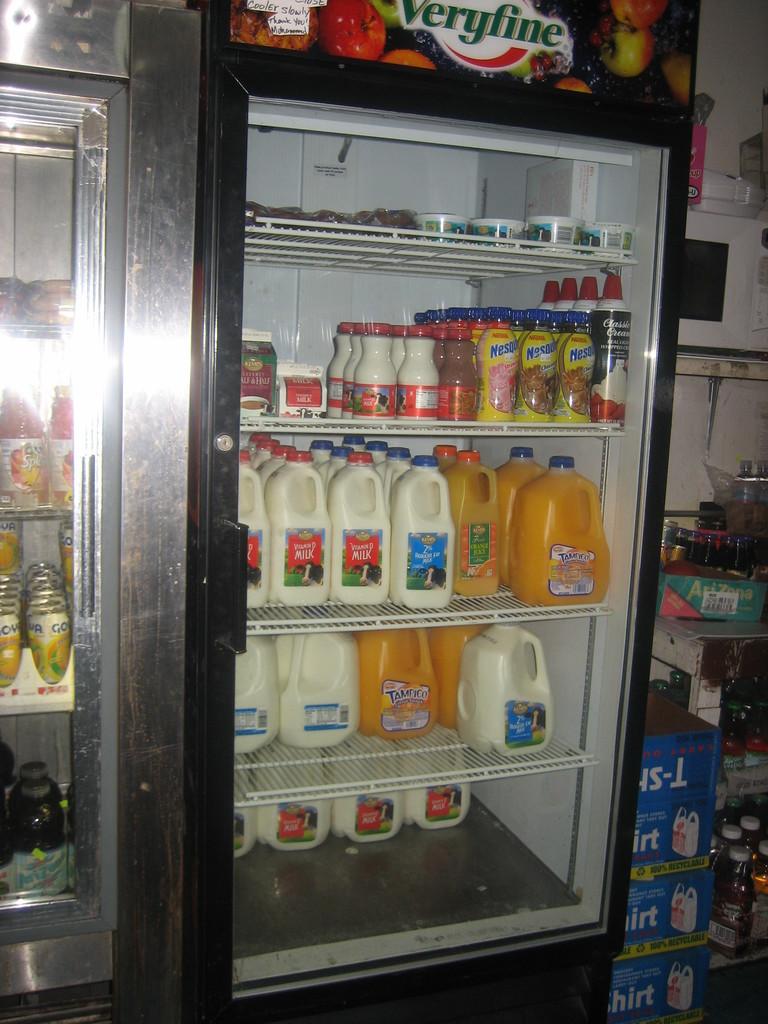Does the machine say veryfine on it?
Make the answer very short. Yes. 